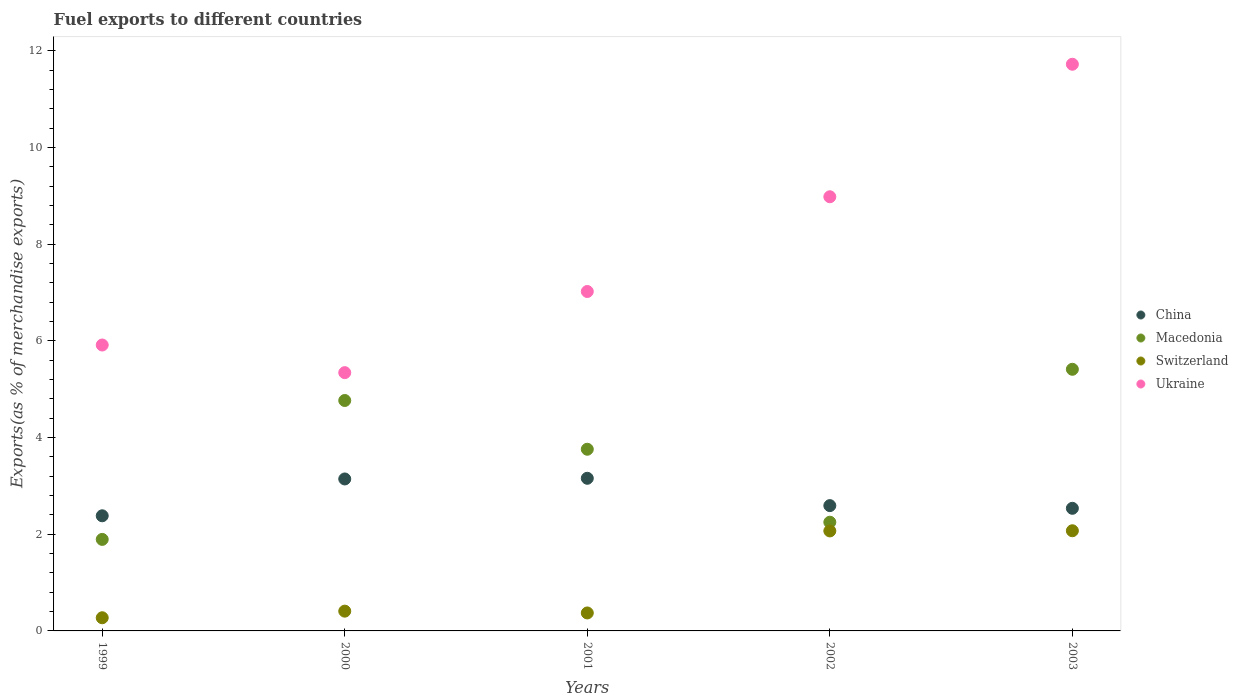How many different coloured dotlines are there?
Provide a short and direct response. 4. Is the number of dotlines equal to the number of legend labels?
Ensure brevity in your answer.  Yes. What is the percentage of exports to different countries in Macedonia in 2002?
Your answer should be compact. 2.25. Across all years, what is the maximum percentage of exports to different countries in China?
Offer a very short reply. 3.16. Across all years, what is the minimum percentage of exports to different countries in Macedonia?
Provide a short and direct response. 1.89. In which year was the percentage of exports to different countries in Ukraine maximum?
Offer a very short reply. 2003. What is the total percentage of exports to different countries in Ukraine in the graph?
Your response must be concise. 38.98. What is the difference between the percentage of exports to different countries in Switzerland in 2002 and that in 2003?
Make the answer very short. -0. What is the difference between the percentage of exports to different countries in Ukraine in 2002 and the percentage of exports to different countries in Switzerland in 1999?
Your answer should be very brief. 8.71. What is the average percentage of exports to different countries in Switzerland per year?
Make the answer very short. 1.04. In the year 2000, what is the difference between the percentage of exports to different countries in China and percentage of exports to different countries in Ukraine?
Provide a succinct answer. -2.2. In how many years, is the percentage of exports to different countries in China greater than 2.8 %?
Your answer should be very brief. 2. What is the ratio of the percentage of exports to different countries in China in 1999 to that in 2002?
Keep it short and to the point. 0.92. What is the difference between the highest and the second highest percentage of exports to different countries in China?
Your answer should be compact. 0.01. What is the difference between the highest and the lowest percentage of exports to different countries in Macedonia?
Keep it short and to the point. 3.52. In how many years, is the percentage of exports to different countries in Macedonia greater than the average percentage of exports to different countries in Macedonia taken over all years?
Give a very brief answer. 3. Is the sum of the percentage of exports to different countries in Macedonia in 1999 and 2002 greater than the maximum percentage of exports to different countries in Ukraine across all years?
Make the answer very short. No. Is it the case that in every year, the sum of the percentage of exports to different countries in Switzerland and percentage of exports to different countries in Macedonia  is greater than the percentage of exports to different countries in China?
Offer a very short reply. No. Does the percentage of exports to different countries in Macedonia monotonically increase over the years?
Keep it short and to the point. No. Is the percentage of exports to different countries in Ukraine strictly less than the percentage of exports to different countries in China over the years?
Your response must be concise. No. How many dotlines are there?
Make the answer very short. 4. What is the difference between two consecutive major ticks on the Y-axis?
Provide a succinct answer. 2. Are the values on the major ticks of Y-axis written in scientific E-notation?
Keep it short and to the point. No. Where does the legend appear in the graph?
Make the answer very short. Center right. How many legend labels are there?
Ensure brevity in your answer.  4. How are the legend labels stacked?
Your answer should be very brief. Vertical. What is the title of the graph?
Your answer should be very brief. Fuel exports to different countries. Does "St. Vincent and the Grenadines" appear as one of the legend labels in the graph?
Offer a very short reply. No. What is the label or title of the Y-axis?
Your answer should be very brief. Exports(as % of merchandise exports). What is the Exports(as % of merchandise exports) of China in 1999?
Provide a succinct answer. 2.38. What is the Exports(as % of merchandise exports) in Macedonia in 1999?
Offer a terse response. 1.89. What is the Exports(as % of merchandise exports) of Switzerland in 1999?
Your answer should be very brief. 0.27. What is the Exports(as % of merchandise exports) of Ukraine in 1999?
Your answer should be very brief. 5.91. What is the Exports(as % of merchandise exports) in China in 2000?
Offer a very short reply. 3.14. What is the Exports(as % of merchandise exports) in Macedonia in 2000?
Provide a short and direct response. 4.77. What is the Exports(as % of merchandise exports) of Switzerland in 2000?
Keep it short and to the point. 0.41. What is the Exports(as % of merchandise exports) of Ukraine in 2000?
Ensure brevity in your answer.  5.34. What is the Exports(as % of merchandise exports) in China in 2001?
Your response must be concise. 3.16. What is the Exports(as % of merchandise exports) in Macedonia in 2001?
Ensure brevity in your answer.  3.76. What is the Exports(as % of merchandise exports) in Switzerland in 2001?
Provide a succinct answer. 0.37. What is the Exports(as % of merchandise exports) in Ukraine in 2001?
Provide a succinct answer. 7.02. What is the Exports(as % of merchandise exports) of China in 2002?
Your response must be concise. 2.59. What is the Exports(as % of merchandise exports) of Macedonia in 2002?
Give a very brief answer. 2.25. What is the Exports(as % of merchandise exports) in Switzerland in 2002?
Your response must be concise. 2.07. What is the Exports(as % of merchandise exports) of Ukraine in 2002?
Offer a very short reply. 8.98. What is the Exports(as % of merchandise exports) of China in 2003?
Your answer should be very brief. 2.54. What is the Exports(as % of merchandise exports) of Macedonia in 2003?
Your response must be concise. 5.41. What is the Exports(as % of merchandise exports) in Switzerland in 2003?
Your answer should be very brief. 2.07. What is the Exports(as % of merchandise exports) of Ukraine in 2003?
Your answer should be compact. 11.72. Across all years, what is the maximum Exports(as % of merchandise exports) in China?
Your answer should be very brief. 3.16. Across all years, what is the maximum Exports(as % of merchandise exports) in Macedonia?
Give a very brief answer. 5.41. Across all years, what is the maximum Exports(as % of merchandise exports) of Switzerland?
Give a very brief answer. 2.07. Across all years, what is the maximum Exports(as % of merchandise exports) of Ukraine?
Ensure brevity in your answer.  11.72. Across all years, what is the minimum Exports(as % of merchandise exports) in China?
Provide a succinct answer. 2.38. Across all years, what is the minimum Exports(as % of merchandise exports) of Macedonia?
Make the answer very short. 1.89. Across all years, what is the minimum Exports(as % of merchandise exports) of Switzerland?
Provide a succinct answer. 0.27. Across all years, what is the minimum Exports(as % of merchandise exports) of Ukraine?
Offer a very short reply. 5.34. What is the total Exports(as % of merchandise exports) of China in the graph?
Provide a short and direct response. 13.81. What is the total Exports(as % of merchandise exports) in Macedonia in the graph?
Give a very brief answer. 18.08. What is the total Exports(as % of merchandise exports) in Switzerland in the graph?
Your answer should be very brief. 5.19. What is the total Exports(as % of merchandise exports) of Ukraine in the graph?
Offer a terse response. 38.98. What is the difference between the Exports(as % of merchandise exports) of China in 1999 and that in 2000?
Your answer should be very brief. -0.76. What is the difference between the Exports(as % of merchandise exports) in Macedonia in 1999 and that in 2000?
Offer a very short reply. -2.87. What is the difference between the Exports(as % of merchandise exports) in Switzerland in 1999 and that in 2000?
Your response must be concise. -0.14. What is the difference between the Exports(as % of merchandise exports) in Ukraine in 1999 and that in 2000?
Your answer should be very brief. 0.57. What is the difference between the Exports(as % of merchandise exports) in China in 1999 and that in 2001?
Your answer should be compact. -0.78. What is the difference between the Exports(as % of merchandise exports) of Macedonia in 1999 and that in 2001?
Make the answer very short. -1.87. What is the difference between the Exports(as % of merchandise exports) of Switzerland in 1999 and that in 2001?
Ensure brevity in your answer.  -0.1. What is the difference between the Exports(as % of merchandise exports) in Ukraine in 1999 and that in 2001?
Keep it short and to the point. -1.11. What is the difference between the Exports(as % of merchandise exports) of China in 1999 and that in 2002?
Your answer should be very brief. -0.21. What is the difference between the Exports(as % of merchandise exports) of Macedonia in 1999 and that in 2002?
Offer a very short reply. -0.36. What is the difference between the Exports(as % of merchandise exports) of Switzerland in 1999 and that in 2002?
Offer a very short reply. -1.8. What is the difference between the Exports(as % of merchandise exports) in Ukraine in 1999 and that in 2002?
Provide a succinct answer. -3.07. What is the difference between the Exports(as % of merchandise exports) in China in 1999 and that in 2003?
Offer a terse response. -0.15. What is the difference between the Exports(as % of merchandise exports) in Macedonia in 1999 and that in 2003?
Offer a very short reply. -3.52. What is the difference between the Exports(as % of merchandise exports) in Switzerland in 1999 and that in 2003?
Provide a short and direct response. -1.8. What is the difference between the Exports(as % of merchandise exports) in Ukraine in 1999 and that in 2003?
Make the answer very short. -5.81. What is the difference between the Exports(as % of merchandise exports) in China in 2000 and that in 2001?
Provide a succinct answer. -0.01. What is the difference between the Exports(as % of merchandise exports) in Macedonia in 2000 and that in 2001?
Your answer should be very brief. 1.01. What is the difference between the Exports(as % of merchandise exports) in Switzerland in 2000 and that in 2001?
Keep it short and to the point. 0.04. What is the difference between the Exports(as % of merchandise exports) in Ukraine in 2000 and that in 2001?
Give a very brief answer. -1.68. What is the difference between the Exports(as % of merchandise exports) in China in 2000 and that in 2002?
Your answer should be compact. 0.55. What is the difference between the Exports(as % of merchandise exports) of Macedonia in 2000 and that in 2002?
Keep it short and to the point. 2.52. What is the difference between the Exports(as % of merchandise exports) of Switzerland in 2000 and that in 2002?
Your answer should be compact. -1.66. What is the difference between the Exports(as % of merchandise exports) in Ukraine in 2000 and that in 2002?
Ensure brevity in your answer.  -3.64. What is the difference between the Exports(as % of merchandise exports) of China in 2000 and that in 2003?
Make the answer very short. 0.61. What is the difference between the Exports(as % of merchandise exports) of Macedonia in 2000 and that in 2003?
Provide a succinct answer. -0.65. What is the difference between the Exports(as % of merchandise exports) of Switzerland in 2000 and that in 2003?
Offer a terse response. -1.66. What is the difference between the Exports(as % of merchandise exports) in Ukraine in 2000 and that in 2003?
Your response must be concise. -6.38. What is the difference between the Exports(as % of merchandise exports) of China in 2001 and that in 2002?
Your answer should be compact. 0.57. What is the difference between the Exports(as % of merchandise exports) in Macedonia in 2001 and that in 2002?
Give a very brief answer. 1.51. What is the difference between the Exports(as % of merchandise exports) in Switzerland in 2001 and that in 2002?
Your answer should be very brief. -1.7. What is the difference between the Exports(as % of merchandise exports) in Ukraine in 2001 and that in 2002?
Your answer should be very brief. -1.96. What is the difference between the Exports(as % of merchandise exports) of China in 2001 and that in 2003?
Provide a succinct answer. 0.62. What is the difference between the Exports(as % of merchandise exports) of Macedonia in 2001 and that in 2003?
Keep it short and to the point. -1.65. What is the difference between the Exports(as % of merchandise exports) of Switzerland in 2001 and that in 2003?
Ensure brevity in your answer.  -1.7. What is the difference between the Exports(as % of merchandise exports) of Ukraine in 2001 and that in 2003?
Provide a succinct answer. -4.7. What is the difference between the Exports(as % of merchandise exports) in China in 2002 and that in 2003?
Ensure brevity in your answer.  0.06. What is the difference between the Exports(as % of merchandise exports) in Macedonia in 2002 and that in 2003?
Keep it short and to the point. -3.16. What is the difference between the Exports(as % of merchandise exports) in Switzerland in 2002 and that in 2003?
Your response must be concise. -0. What is the difference between the Exports(as % of merchandise exports) of Ukraine in 2002 and that in 2003?
Offer a very short reply. -2.74. What is the difference between the Exports(as % of merchandise exports) of China in 1999 and the Exports(as % of merchandise exports) of Macedonia in 2000?
Provide a short and direct response. -2.39. What is the difference between the Exports(as % of merchandise exports) in China in 1999 and the Exports(as % of merchandise exports) in Switzerland in 2000?
Your answer should be compact. 1.97. What is the difference between the Exports(as % of merchandise exports) of China in 1999 and the Exports(as % of merchandise exports) of Ukraine in 2000?
Your answer should be very brief. -2.96. What is the difference between the Exports(as % of merchandise exports) in Macedonia in 1999 and the Exports(as % of merchandise exports) in Switzerland in 2000?
Ensure brevity in your answer.  1.48. What is the difference between the Exports(as % of merchandise exports) in Macedonia in 1999 and the Exports(as % of merchandise exports) in Ukraine in 2000?
Make the answer very short. -3.45. What is the difference between the Exports(as % of merchandise exports) in Switzerland in 1999 and the Exports(as % of merchandise exports) in Ukraine in 2000?
Your answer should be very brief. -5.07. What is the difference between the Exports(as % of merchandise exports) in China in 1999 and the Exports(as % of merchandise exports) in Macedonia in 2001?
Provide a succinct answer. -1.38. What is the difference between the Exports(as % of merchandise exports) of China in 1999 and the Exports(as % of merchandise exports) of Switzerland in 2001?
Ensure brevity in your answer.  2.01. What is the difference between the Exports(as % of merchandise exports) of China in 1999 and the Exports(as % of merchandise exports) of Ukraine in 2001?
Your response must be concise. -4.64. What is the difference between the Exports(as % of merchandise exports) in Macedonia in 1999 and the Exports(as % of merchandise exports) in Switzerland in 2001?
Your answer should be very brief. 1.52. What is the difference between the Exports(as % of merchandise exports) in Macedonia in 1999 and the Exports(as % of merchandise exports) in Ukraine in 2001?
Ensure brevity in your answer.  -5.13. What is the difference between the Exports(as % of merchandise exports) in Switzerland in 1999 and the Exports(as % of merchandise exports) in Ukraine in 2001?
Provide a succinct answer. -6.75. What is the difference between the Exports(as % of merchandise exports) in China in 1999 and the Exports(as % of merchandise exports) in Macedonia in 2002?
Provide a succinct answer. 0.13. What is the difference between the Exports(as % of merchandise exports) of China in 1999 and the Exports(as % of merchandise exports) of Switzerland in 2002?
Offer a terse response. 0.31. What is the difference between the Exports(as % of merchandise exports) of China in 1999 and the Exports(as % of merchandise exports) of Ukraine in 2002?
Keep it short and to the point. -6.6. What is the difference between the Exports(as % of merchandise exports) of Macedonia in 1999 and the Exports(as % of merchandise exports) of Switzerland in 2002?
Offer a terse response. -0.18. What is the difference between the Exports(as % of merchandise exports) in Macedonia in 1999 and the Exports(as % of merchandise exports) in Ukraine in 2002?
Give a very brief answer. -7.09. What is the difference between the Exports(as % of merchandise exports) in Switzerland in 1999 and the Exports(as % of merchandise exports) in Ukraine in 2002?
Provide a short and direct response. -8.71. What is the difference between the Exports(as % of merchandise exports) of China in 1999 and the Exports(as % of merchandise exports) of Macedonia in 2003?
Your answer should be very brief. -3.03. What is the difference between the Exports(as % of merchandise exports) in China in 1999 and the Exports(as % of merchandise exports) in Switzerland in 2003?
Make the answer very short. 0.31. What is the difference between the Exports(as % of merchandise exports) in China in 1999 and the Exports(as % of merchandise exports) in Ukraine in 2003?
Offer a very short reply. -9.34. What is the difference between the Exports(as % of merchandise exports) in Macedonia in 1999 and the Exports(as % of merchandise exports) in Switzerland in 2003?
Offer a very short reply. -0.18. What is the difference between the Exports(as % of merchandise exports) in Macedonia in 1999 and the Exports(as % of merchandise exports) in Ukraine in 2003?
Provide a short and direct response. -9.83. What is the difference between the Exports(as % of merchandise exports) in Switzerland in 1999 and the Exports(as % of merchandise exports) in Ukraine in 2003?
Offer a terse response. -11.45. What is the difference between the Exports(as % of merchandise exports) of China in 2000 and the Exports(as % of merchandise exports) of Macedonia in 2001?
Your response must be concise. -0.61. What is the difference between the Exports(as % of merchandise exports) in China in 2000 and the Exports(as % of merchandise exports) in Switzerland in 2001?
Ensure brevity in your answer.  2.77. What is the difference between the Exports(as % of merchandise exports) of China in 2000 and the Exports(as % of merchandise exports) of Ukraine in 2001?
Your answer should be very brief. -3.88. What is the difference between the Exports(as % of merchandise exports) in Macedonia in 2000 and the Exports(as % of merchandise exports) in Switzerland in 2001?
Offer a very short reply. 4.4. What is the difference between the Exports(as % of merchandise exports) in Macedonia in 2000 and the Exports(as % of merchandise exports) in Ukraine in 2001?
Your answer should be compact. -2.25. What is the difference between the Exports(as % of merchandise exports) of Switzerland in 2000 and the Exports(as % of merchandise exports) of Ukraine in 2001?
Provide a succinct answer. -6.61. What is the difference between the Exports(as % of merchandise exports) of China in 2000 and the Exports(as % of merchandise exports) of Macedonia in 2002?
Your response must be concise. 0.89. What is the difference between the Exports(as % of merchandise exports) in China in 2000 and the Exports(as % of merchandise exports) in Switzerland in 2002?
Your answer should be compact. 1.07. What is the difference between the Exports(as % of merchandise exports) of China in 2000 and the Exports(as % of merchandise exports) of Ukraine in 2002?
Offer a terse response. -5.84. What is the difference between the Exports(as % of merchandise exports) in Macedonia in 2000 and the Exports(as % of merchandise exports) in Switzerland in 2002?
Offer a terse response. 2.7. What is the difference between the Exports(as % of merchandise exports) in Macedonia in 2000 and the Exports(as % of merchandise exports) in Ukraine in 2002?
Offer a very short reply. -4.21. What is the difference between the Exports(as % of merchandise exports) of Switzerland in 2000 and the Exports(as % of merchandise exports) of Ukraine in 2002?
Give a very brief answer. -8.57. What is the difference between the Exports(as % of merchandise exports) of China in 2000 and the Exports(as % of merchandise exports) of Macedonia in 2003?
Provide a succinct answer. -2.27. What is the difference between the Exports(as % of merchandise exports) in China in 2000 and the Exports(as % of merchandise exports) in Switzerland in 2003?
Provide a succinct answer. 1.07. What is the difference between the Exports(as % of merchandise exports) of China in 2000 and the Exports(as % of merchandise exports) of Ukraine in 2003?
Your answer should be very brief. -8.58. What is the difference between the Exports(as % of merchandise exports) of Macedonia in 2000 and the Exports(as % of merchandise exports) of Switzerland in 2003?
Offer a terse response. 2.69. What is the difference between the Exports(as % of merchandise exports) of Macedonia in 2000 and the Exports(as % of merchandise exports) of Ukraine in 2003?
Your answer should be compact. -6.96. What is the difference between the Exports(as % of merchandise exports) in Switzerland in 2000 and the Exports(as % of merchandise exports) in Ukraine in 2003?
Your answer should be very brief. -11.31. What is the difference between the Exports(as % of merchandise exports) of China in 2001 and the Exports(as % of merchandise exports) of Macedonia in 2002?
Provide a succinct answer. 0.91. What is the difference between the Exports(as % of merchandise exports) in China in 2001 and the Exports(as % of merchandise exports) in Switzerland in 2002?
Your answer should be very brief. 1.09. What is the difference between the Exports(as % of merchandise exports) in China in 2001 and the Exports(as % of merchandise exports) in Ukraine in 2002?
Your answer should be very brief. -5.82. What is the difference between the Exports(as % of merchandise exports) of Macedonia in 2001 and the Exports(as % of merchandise exports) of Switzerland in 2002?
Provide a short and direct response. 1.69. What is the difference between the Exports(as % of merchandise exports) of Macedonia in 2001 and the Exports(as % of merchandise exports) of Ukraine in 2002?
Give a very brief answer. -5.22. What is the difference between the Exports(as % of merchandise exports) of Switzerland in 2001 and the Exports(as % of merchandise exports) of Ukraine in 2002?
Make the answer very short. -8.61. What is the difference between the Exports(as % of merchandise exports) of China in 2001 and the Exports(as % of merchandise exports) of Macedonia in 2003?
Ensure brevity in your answer.  -2.25. What is the difference between the Exports(as % of merchandise exports) of China in 2001 and the Exports(as % of merchandise exports) of Switzerland in 2003?
Make the answer very short. 1.09. What is the difference between the Exports(as % of merchandise exports) of China in 2001 and the Exports(as % of merchandise exports) of Ukraine in 2003?
Provide a short and direct response. -8.57. What is the difference between the Exports(as % of merchandise exports) in Macedonia in 2001 and the Exports(as % of merchandise exports) in Switzerland in 2003?
Your answer should be compact. 1.69. What is the difference between the Exports(as % of merchandise exports) in Macedonia in 2001 and the Exports(as % of merchandise exports) in Ukraine in 2003?
Your response must be concise. -7.96. What is the difference between the Exports(as % of merchandise exports) in Switzerland in 2001 and the Exports(as % of merchandise exports) in Ukraine in 2003?
Offer a terse response. -11.35. What is the difference between the Exports(as % of merchandise exports) in China in 2002 and the Exports(as % of merchandise exports) in Macedonia in 2003?
Provide a short and direct response. -2.82. What is the difference between the Exports(as % of merchandise exports) of China in 2002 and the Exports(as % of merchandise exports) of Switzerland in 2003?
Give a very brief answer. 0.52. What is the difference between the Exports(as % of merchandise exports) in China in 2002 and the Exports(as % of merchandise exports) in Ukraine in 2003?
Ensure brevity in your answer.  -9.13. What is the difference between the Exports(as % of merchandise exports) in Macedonia in 2002 and the Exports(as % of merchandise exports) in Switzerland in 2003?
Provide a short and direct response. 0.18. What is the difference between the Exports(as % of merchandise exports) of Macedonia in 2002 and the Exports(as % of merchandise exports) of Ukraine in 2003?
Your answer should be compact. -9.47. What is the difference between the Exports(as % of merchandise exports) in Switzerland in 2002 and the Exports(as % of merchandise exports) in Ukraine in 2003?
Provide a short and direct response. -9.65. What is the average Exports(as % of merchandise exports) in China per year?
Make the answer very short. 2.76. What is the average Exports(as % of merchandise exports) of Macedonia per year?
Ensure brevity in your answer.  3.62. What is the average Exports(as % of merchandise exports) in Switzerland per year?
Offer a very short reply. 1.04. What is the average Exports(as % of merchandise exports) in Ukraine per year?
Your answer should be compact. 7.8. In the year 1999, what is the difference between the Exports(as % of merchandise exports) of China and Exports(as % of merchandise exports) of Macedonia?
Provide a short and direct response. 0.49. In the year 1999, what is the difference between the Exports(as % of merchandise exports) of China and Exports(as % of merchandise exports) of Switzerland?
Ensure brevity in your answer.  2.11. In the year 1999, what is the difference between the Exports(as % of merchandise exports) in China and Exports(as % of merchandise exports) in Ukraine?
Offer a very short reply. -3.53. In the year 1999, what is the difference between the Exports(as % of merchandise exports) in Macedonia and Exports(as % of merchandise exports) in Switzerland?
Your answer should be compact. 1.62. In the year 1999, what is the difference between the Exports(as % of merchandise exports) in Macedonia and Exports(as % of merchandise exports) in Ukraine?
Your answer should be compact. -4.02. In the year 1999, what is the difference between the Exports(as % of merchandise exports) in Switzerland and Exports(as % of merchandise exports) in Ukraine?
Provide a succinct answer. -5.64. In the year 2000, what is the difference between the Exports(as % of merchandise exports) of China and Exports(as % of merchandise exports) of Macedonia?
Ensure brevity in your answer.  -1.62. In the year 2000, what is the difference between the Exports(as % of merchandise exports) in China and Exports(as % of merchandise exports) in Switzerland?
Offer a terse response. 2.73. In the year 2000, what is the difference between the Exports(as % of merchandise exports) in China and Exports(as % of merchandise exports) in Ukraine?
Offer a terse response. -2.2. In the year 2000, what is the difference between the Exports(as % of merchandise exports) of Macedonia and Exports(as % of merchandise exports) of Switzerland?
Make the answer very short. 4.36. In the year 2000, what is the difference between the Exports(as % of merchandise exports) of Macedonia and Exports(as % of merchandise exports) of Ukraine?
Your answer should be very brief. -0.58. In the year 2000, what is the difference between the Exports(as % of merchandise exports) in Switzerland and Exports(as % of merchandise exports) in Ukraine?
Your response must be concise. -4.93. In the year 2001, what is the difference between the Exports(as % of merchandise exports) in China and Exports(as % of merchandise exports) in Macedonia?
Give a very brief answer. -0.6. In the year 2001, what is the difference between the Exports(as % of merchandise exports) of China and Exports(as % of merchandise exports) of Switzerland?
Give a very brief answer. 2.79. In the year 2001, what is the difference between the Exports(as % of merchandise exports) of China and Exports(as % of merchandise exports) of Ukraine?
Your response must be concise. -3.86. In the year 2001, what is the difference between the Exports(as % of merchandise exports) in Macedonia and Exports(as % of merchandise exports) in Switzerland?
Keep it short and to the point. 3.39. In the year 2001, what is the difference between the Exports(as % of merchandise exports) in Macedonia and Exports(as % of merchandise exports) in Ukraine?
Offer a terse response. -3.26. In the year 2001, what is the difference between the Exports(as % of merchandise exports) in Switzerland and Exports(as % of merchandise exports) in Ukraine?
Make the answer very short. -6.65. In the year 2002, what is the difference between the Exports(as % of merchandise exports) of China and Exports(as % of merchandise exports) of Macedonia?
Provide a succinct answer. 0.34. In the year 2002, what is the difference between the Exports(as % of merchandise exports) in China and Exports(as % of merchandise exports) in Switzerland?
Offer a terse response. 0.52. In the year 2002, what is the difference between the Exports(as % of merchandise exports) in China and Exports(as % of merchandise exports) in Ukraine?
Offer a terse response. -6.39. In the year 2002, what is the difference between the Exports(as % of merchandise exports) in Macedonia and Exports(as % of merchandise exports) in Switzerland?
Your response must be concise. 0.18. In the year 2002, what is the difference between the Exports(as % of merchandise exports) in Macedonia and Exports(as % of merchandise exports) in Ukraine?
Ensure brevity in your answer.  -6.73. In the year 2002, what is the difference between the Exports(as % of merchandise exports) in Switzerland and Exports(as % of merchandise exports) in Ukraine?
Your answer should be very brief. -6.91. In the year 2003, what is the difference between the Exports(as % of merchandise exports) of China and Exports(as % of merchandise exports) of Macedonia?
Provide a succinct answer. -2.88. In the year 2003, what is the difference between the Exports(as % of merchandise exports) in China and Exports(as % of merchandise exports) in Switzerland?
Provide a short and direct response. 0.46. In the year 2003, what is the difference between the Exports(as % of merchandise exports) of China and Exports(as % of merchandise exports) of Ukraine?
Your answer should be compact. -9.19. In the year 2003, what is the difference between the Exports(as % of merchandise exports) in Macedonia and Exports(as % of merchandise exports) in Switzerland?
Offer a terse response. 3.34. In the year 2003, what is the difference between the Exports(as % of merchandise exports) in Macedonia and Exports(as % of merchandise exports) in Ukraine?
Make the answer very short. -6.31. In the year 2003, what is the difference between the Exports(as % of merchandise exports) in Switzerland and Exports(as % of merchandise exports) in Ukraine?
Your response must be concise. -9.65. What is the ratio of the Exports(as % of merchandise exports) of China in 1999 to that in 2000?
Your answer should be very brief. 0.76. What is the ratio of the Exports(as % of merchandise exports) of Macedonia in 1999 to that in 2000?
Offer a very short reply. 0.4. What is the ratio of the Exports(as % of merchandise exports) of Switzerland in 1999 to that in 2000?
Make the answer very short. 0.67. What is the ratio of the Exports(as % of merchandise exports) of Ukraine in 1999 to that in 2000?
Your response must be concise. 1.11. What is the ratio of the Exports(as % of merchandise exports) of China in 1999 to that in 2001?
Your response must be concise. 0.75. What is the ratio of the Exports(as % of merchandise exports) in Macedonia in 1999 to that in 2001?
Ensure brevity in your answer.  0.5. What is the ratio of the Exports(as % of merchandise exports) of Switzerland in 1999 to that in 2001?
Give a very brief answer. 0.73. What is the ratio of the Exports(as % of merchandise exports) of Ukraine in 1999 to that in 2001?
Give a very brief answer. 0.84. What is the ratio of the Exports(as % of merchandise exports) in China in 1999 to that in 2002?
Offer a terse response. 0.92. What is the ratio of the Exports(as % of merchandise exports) in Macedonia in 1999 to that in 2002?
Provide a succinct answer. 0.84. What is the ratio of the Exports(as % of merchandise exports) of Switzerland in 1999 to that in 2002?
Your response must be concise. 0.13. What is the ratio of the Exports(as % of merchandise exports) of Ukraine in 1999 to that in 2002?
Offer a terse response. 0.66. What is the ratio of the Exports(as % of merchandise exports) in China in 1999 to that in 2003?
Your answer should be compact. 0.94. What is the ratio of the Exports(as % of merchandise exports) in Macedonia in 1999 to that in 2003?
Keep it short and to the point. 0.35. What is the ratio of the Exports(as % of merchandise exports) in Switzerland in 1999 to that in 2003?
Offer a terse response. 0.13. What is the ratio of the Exports(as % of merchandise exports) in Ukraine in 1999 to that in 2003?
Offer a very short reply. 0.5. What is the ratio of the Exports(as % of merchandise exports) in China in 2000 to that in 2001?
Keep it short and to the point. 1. What is the ratio of the Exports(as % of merchandise exports) in Macedonia in 2000 to that in 2001?
Keep it short and to the point. 1.27. What is the ratio of the Exports(as % of merchandise exports) of Switzerland in 2000 to that in 2001?
Your answer should be very brief. 1.1. What is the ratio of the Exports(as % of merchandise exports) of Ukraine in 2000 to that in 2001?
Ensure brevity in your answer.  0.76. What is the ratio of the Exports(as % of merchandise exports) of China in 2000 to that in 2002?
Offer a terse response. 1.21. What is the ratio of the Exports(as % of merchandise exports) of Macedonia in 2000 to that in 2002?
Your answer should be very brief. 2.12. What is the ratio of the Exports(as % of merchandise exports) of Switzerland in 2000 to that in 2002?
Make the answer very short. 0.2. What is the ratio of the Exports(as % of merchandise exports) in Ukraine in 2000 to that in 2002?
Make the answer very short. 0.59. What is the ratio of the Exports(as % of merchandise exports) of China in 2000 to that in 2003?
Your answer should be compact. 1.24. What is the ratio of the Exports(as % of merchandise exports) of Macedonia in 2000 to that in 2003?
Ensure brevity in your answer.  0.88. What is the ratio of the Exports(as % of merchandise exports) in Switzerland in 2000 to that in 2003?
Your answer should be compact. 0.2. What is the ratio of the Exports(as % of merchandise exports) of Ukraine in 2000 to that in 2003?
Keep it short and to the point. 0.46. What is the ratio of the Exports(as % of merchandise exports) in China in 2001 to that in 2002?
Your response must be concise. 1.22. What is the ratio of the Exports(as % of merchandise exports) in Macedonia in 2001 to that in 2002?
Your answer should be compact. 1.67. What is the ratio of the Exports(as % of merchandise exports) of Switzerland in 2001 to that in 2002?
Provide a short and direct response. 0.18. What is the ratio of the Exports(as % of merchandise exports) of Ukraine in 2001 to that in 2002?
Your answer should be compact. 0.78. What is the ratio of the Exports(as % of merchandise exports) of China in 2001 to that in 2003?
Your answer should be compact. 1.24. What is the ratio of the Exports(as % of merchandise exports) in Macedonia in 2001 to that in 2003?
Give a very brief answer. 0.69. What is the ratio of the Exports(as % of merchandise exports) in Switzerland in 2001 to that in 2003?
Your answer should be compact. 0.18. What is the ratio of the Exports(as % of merchandise exports) in Ukraine in 2001 to that in 2003?
Keep it short and to the point. 0.6. What is the ratio of the Exports(as % of merchandise exports) in Macedonia in 2002 to that in 2003?
Offer a very short reply. 0.42. What is the ratio of the Exports(as % of merchandise exports) in Switzerland in 2002 to that in 2003?
Give a very brief answer. 1. What is the ratio of the Exports(as % of merchandise exports) in Ukraine in 2002 to that in 2003?
Your answer should be compact. 0.77. What is the difference between the highest and the second highest Exports(as % of merchandise exports) of China?
Your response must be concise. 0.01. What is the difference between the highest and the second highest Exports(as % of merchandise exports) in Macedonia?
Your answer should be very brief. 0.65. What is the difference between the highest and the second highest Exports(as % of merchandise exports) in Switzerland?
Make the answer very short. 0. What is the difference between the highest and the second highest Exports(as % of merchandise exports) in Ukraine?
Offer a terse response. 2.74. What is the difference between the highest and the lowest Exports(as % of merchandise exports) in China?
Ensure brevity in your answer.  0.78. What is the difference between the highest and the lowest Exports(as % of merchandise exports) in Macedonia?
Keep it short and to the point. 3.52. What is the difference between the highest and the lowest Exports(as % of merchandise exports) in Switzerland?
Your response must be concise. 1.8. What is the difference between the highest and the lowest Exports(as % of merchandise exports) of Ukraine?
Provide a succinct answer. 6.38. 